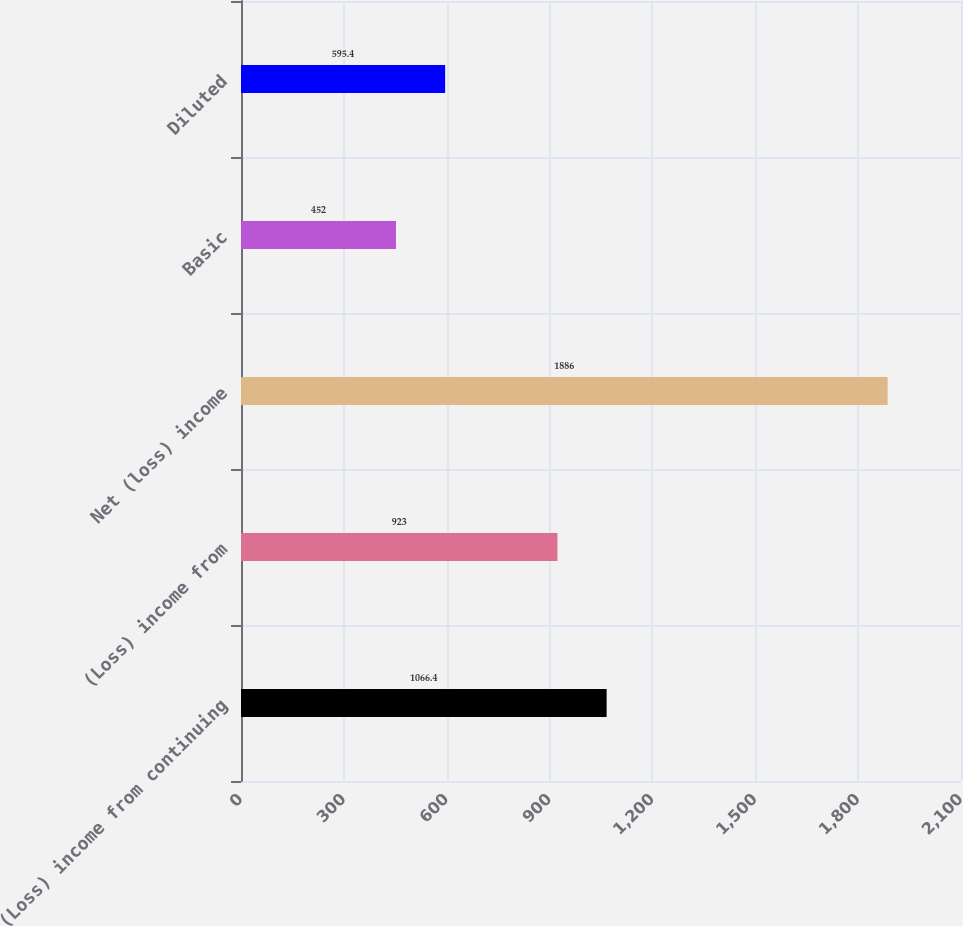Convert chart. <chart><loc_0><loc_0><loc_500><loc_500><bar_chart><fcel>(Loss) income from continuing<fcel>(Loss) income from<fcel>Net (loss) income<fcel>Basic<fcel>Diluted<nl><fcel>1066.4<fcel>923<fcel>1886<fcel>452<fcel>595.4<nl></chart> 